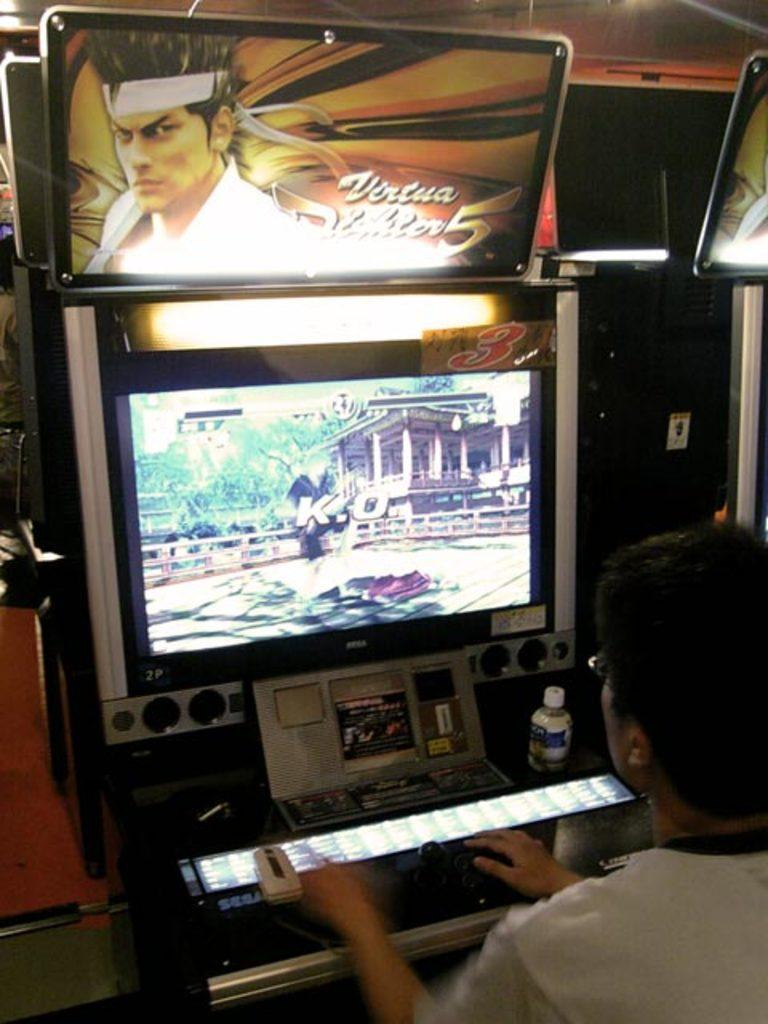<image>
Describe the image concisely. the number 5 that is on an arcade game 